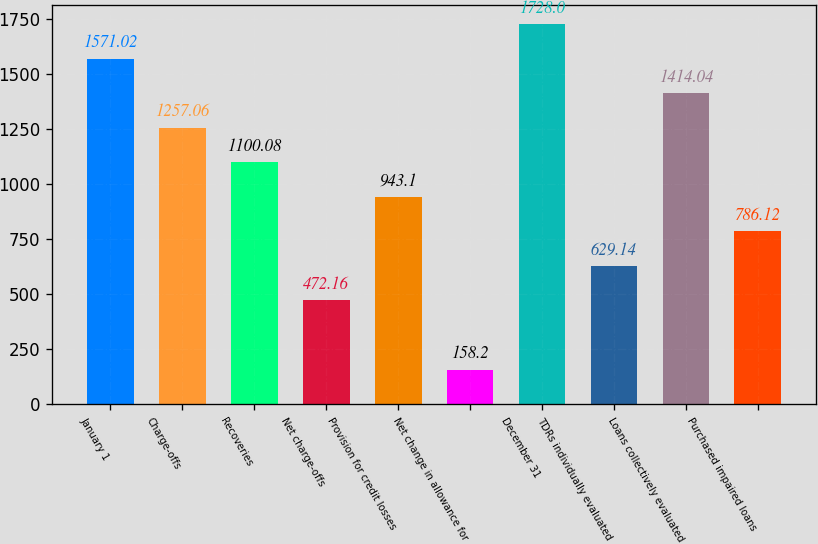Convert chart to OTSL. <chart><loc_0><loc_0><loc_500><loc_500><bar_chart><fcel>January 1<fcel>Charge-offs<fcel>Recoveries<fcel>Net charge-offs<fcel>Provision for credit losses<fcel>Net change in allowance for<fcel>December 31<fcel>TDRs individually evaluated<fcel>Loans collectively evaluated<fcel>Purchased impaired loans<nl><fcel>1571.02<fcel>1257.06<fcel>1100.08<fcel>472.16<fcel>943.1<fcel>158.2<fcel>1728<fcel>629.14<fcel>1414.04<fcel>786.12<nl></chart> 